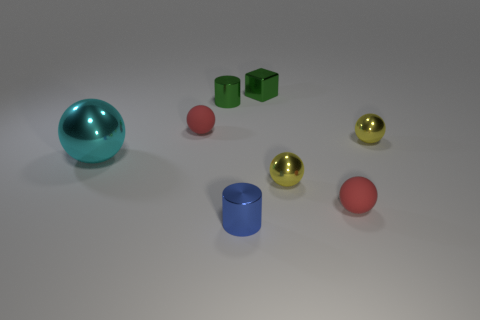Subtract all cyan spheres. How many spheres are left? 4 Subtract all red spheres. How many spheres are left? 3 Subtract all cylinders. How many objects are left? 6 Subtract all yellow balls. How many green cylinders are left? 1 Subtract all tiny cylinders. Subtract all tiny cylinders. How many objects are left? 4 Add 2 small green objects. How many small green objects are left? 4 Add 6 small yellow rubber cubes. How many small yellow rubber cubes exist? 6 Add 1 tiny blocks. How many objects exist? 9 Subtract 0 blue balls. How many objects are left? 8 Subtract 2 spheres. How many spheres are left? 3 